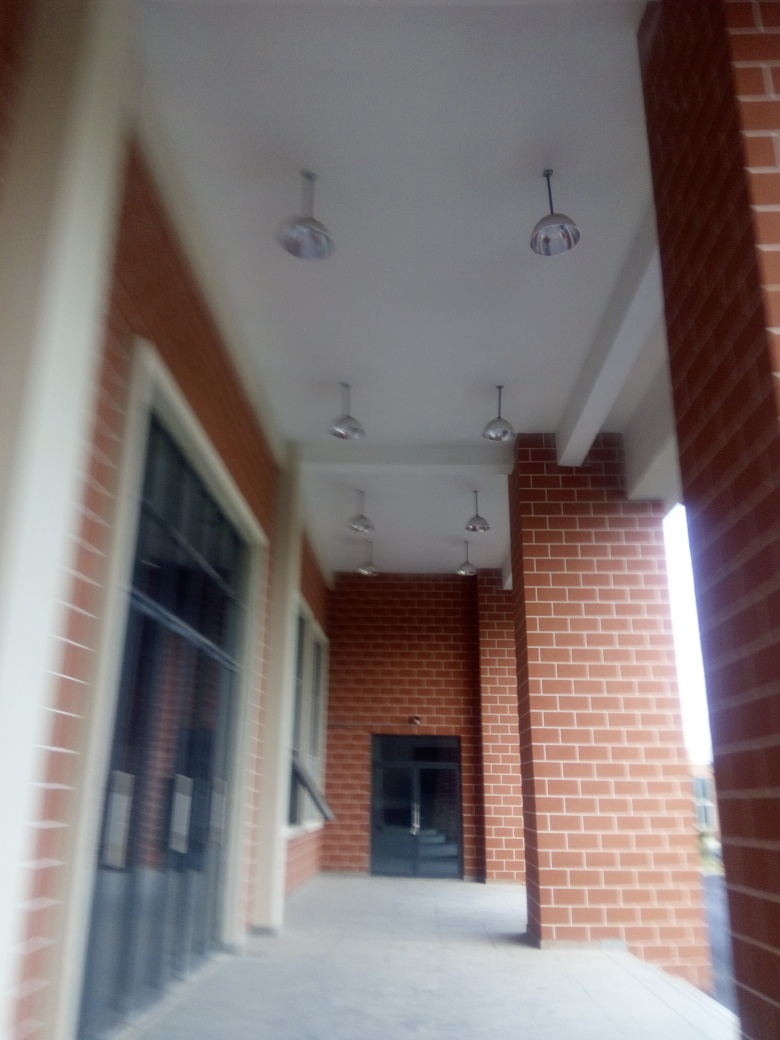What architectural style does this building exhibit? The building features elements typical of modern utilitarian architecture, such as the use of red bricks and functional geometric forms, albeit the image's blurriness makes it hard to discern more intricate details. What might be the purpose of this building? Given the corridor-like space, pendant lighting, and presence of doors to a possibly larger interior, it suggests a commercial or institutional use, such as offices or educational facilities. 